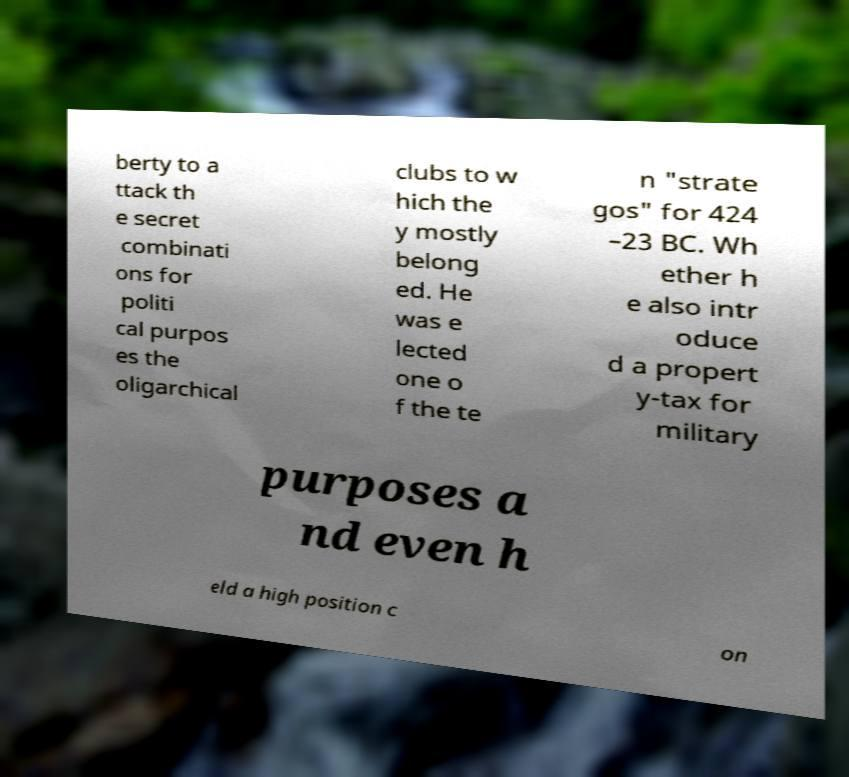Could you extract and type out the text from this image? berty to a ttack th e secret combinati ons for politi cal purpos es the oligarchical clubs to w hich the y mostly belong ed. He was e lected one o f the te n "strate gos" for 424 –23 BC. Wh ether h e also intr oduce d a propert y-tax for military purposes a nd even h eld a high position c on 